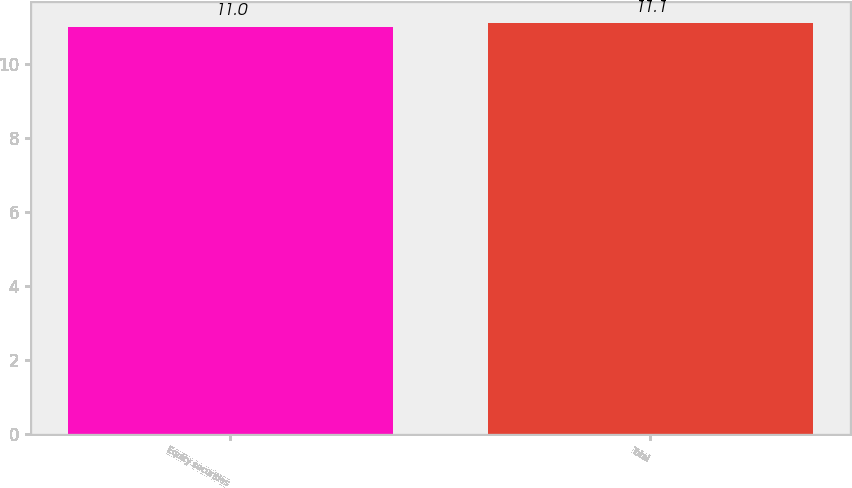Convert chart to OTSL. <chart><loc_0><loc_0><loc_500><loc_500><bar_chart><fcel>Equity securities<fcel>Total<nl><fcel>11<fcel>11.1<nl></chart> 